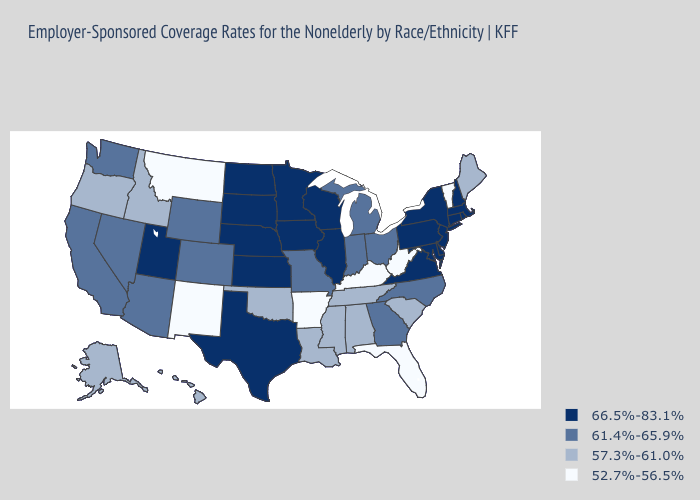Name the states that have a value in the range 61.4%-65.9%?
Short answer required. Arizona, California, Colorado, Georgia, Indiana, Michigan, Missouri, Nevada, North Carolina, Ohio, Washington, Wyoming. What is the value of New York?
Give a very brief answer. 66.5%-83.1%. Does Delaware have the highest value in the South?
Answer briefly. Yes. What is the highest value in states that border Georgia?
Give a very brief answer. 61.4%-65.9%. Name the states that have a value in the range 57.3%-61.0%?
Be succinct. Alabama, Alaska, Hawaii, Idaho, Louisiana, Maine, Mississippi, Oklahoma, Oregon, South Carolina, Tennessee. What is the value of Wyoming?
Short answer required. 61.4%-65.9%. Does New Mexico have the lowest value in the West?
Concise answer only. Yes. What is the value of Kentucky?
Quick response, please. 52.7%-56.5%. Does the map have missing data?
Be succinct. No. What is the value of Maryland?
Short answer required. 66.5%-83.1%. Does Vermont have the highest value in the USA?
Keep it brief. No. What is the lowest value in the West?
Answer briefly. 52.7%-56.5%. Does Florida have a higher value than Louisiana?
Short answer required. No. What is the lowest value in states that border Nevada?
Give a very brief answer. 57.3%-61.0%. Which states hav the highest value in the Northeast?
Concise answer only. Connecticut, Massachusetts, New Hampshire, New Jersey, New York, Pennsylvania, Rhode Island. 